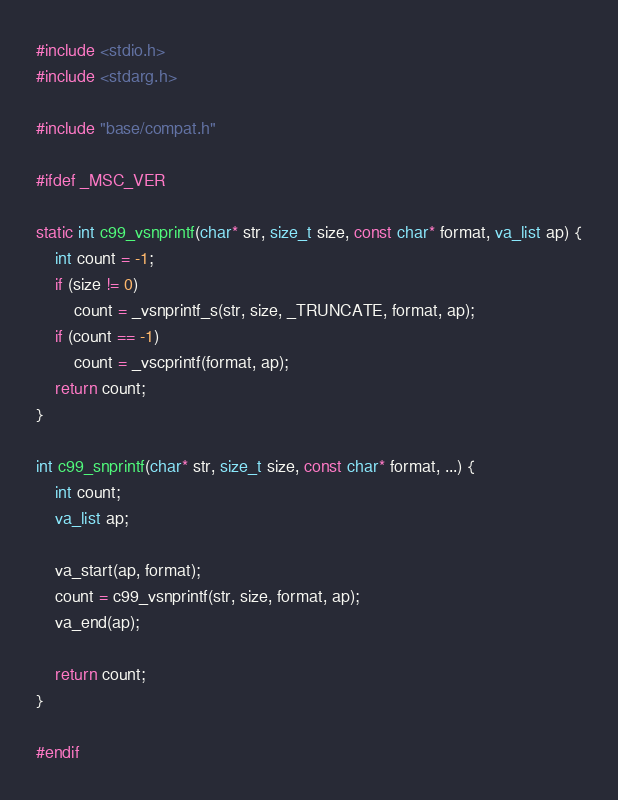<code> <loc_0><loc_0><loc_500><loc_500><_C++_>#include <stdio.h>
#include <stdarg.h>

#include "base/compat.h"

#ifdef _MSC_VER

static int c99_vsnprintf(char* str, size_t size, const char* format, va_list ap) {
	int count = -1;
	if (size != 0)
		count = _vsnprintf_s(str, size, _TRUNCATE, format, ap);
	if (count == -1)
		count = _vscprintf(format, ap);
	return count;
}

int c99_snprintf(char* str, size_t size, const char* format, ...) {
	int count;
	va_list ap;

	va_start(ap, format);
	count = c99_vsnprintf(str, size, format, ap);
	va_end(ap);

	return count;
}

#endif</code> 